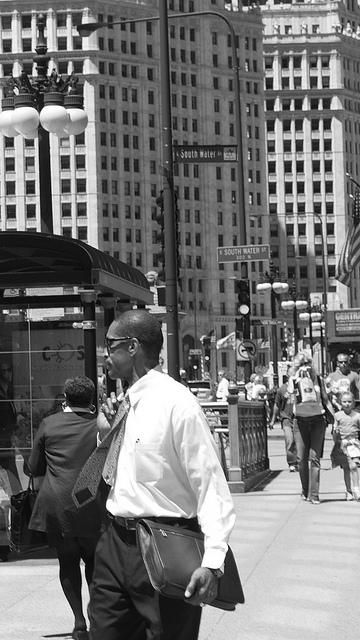What does the fenced in area behind the man lead to?

Choices:
A) subway
B) park
C) jail
D) deli subway 